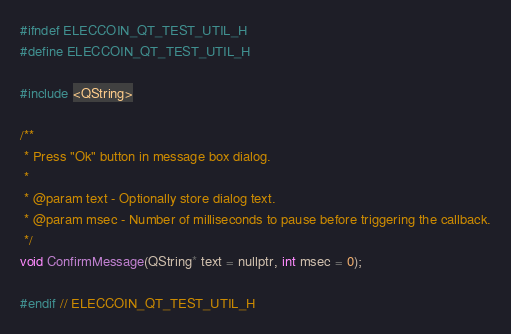Convert code to text. <code><loc_0><loc_0><loc_500><loc_500><_C_>#ifndef ELECCOIN_QT_TEST_UTIL_H
#define ELECCOIN_QT_TEST_UTIL_H

#include <QString>

/**
 * Press "Ok" button in message box dialog.
 *
 * @param text - Optionally store dialog text.
 * @param msec - Number of milliseconds to pause before triggering the callback.
 */
void ConfirmMessage(QString* text = nullptr, int msec = 0);

#endif // ELECCOIN_QT_TEST_UTIL_H
</code> 